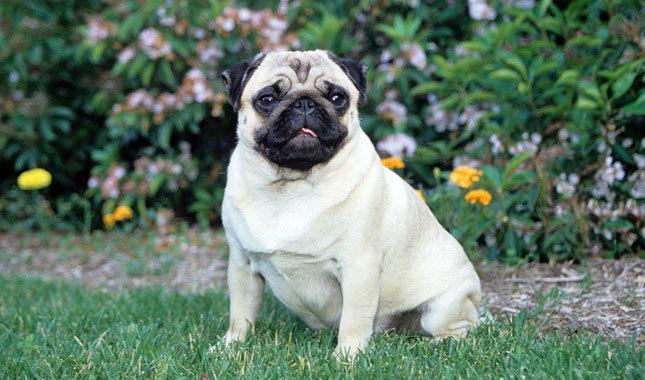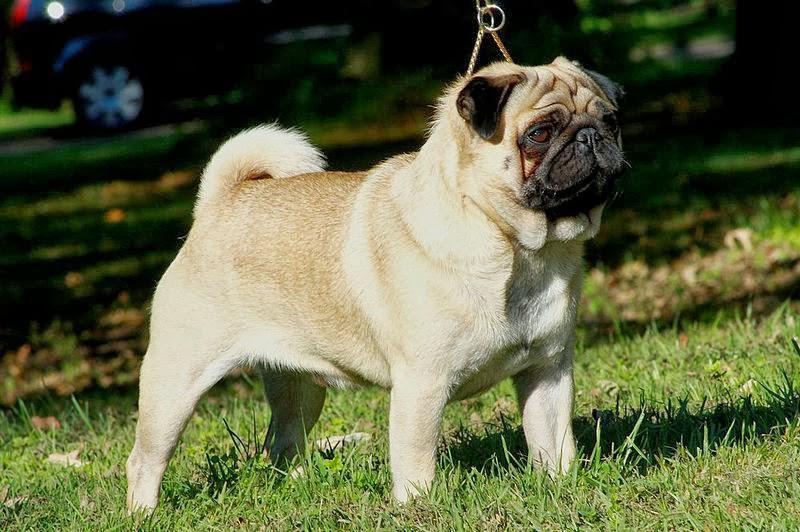The first image is the image on the left, the second image is the image on the right. Evaluate the accuracy of this statement regarding the images: "The lighter colored dog is sitting in the grass.". Is it true? Answer yes or no. Yes. 